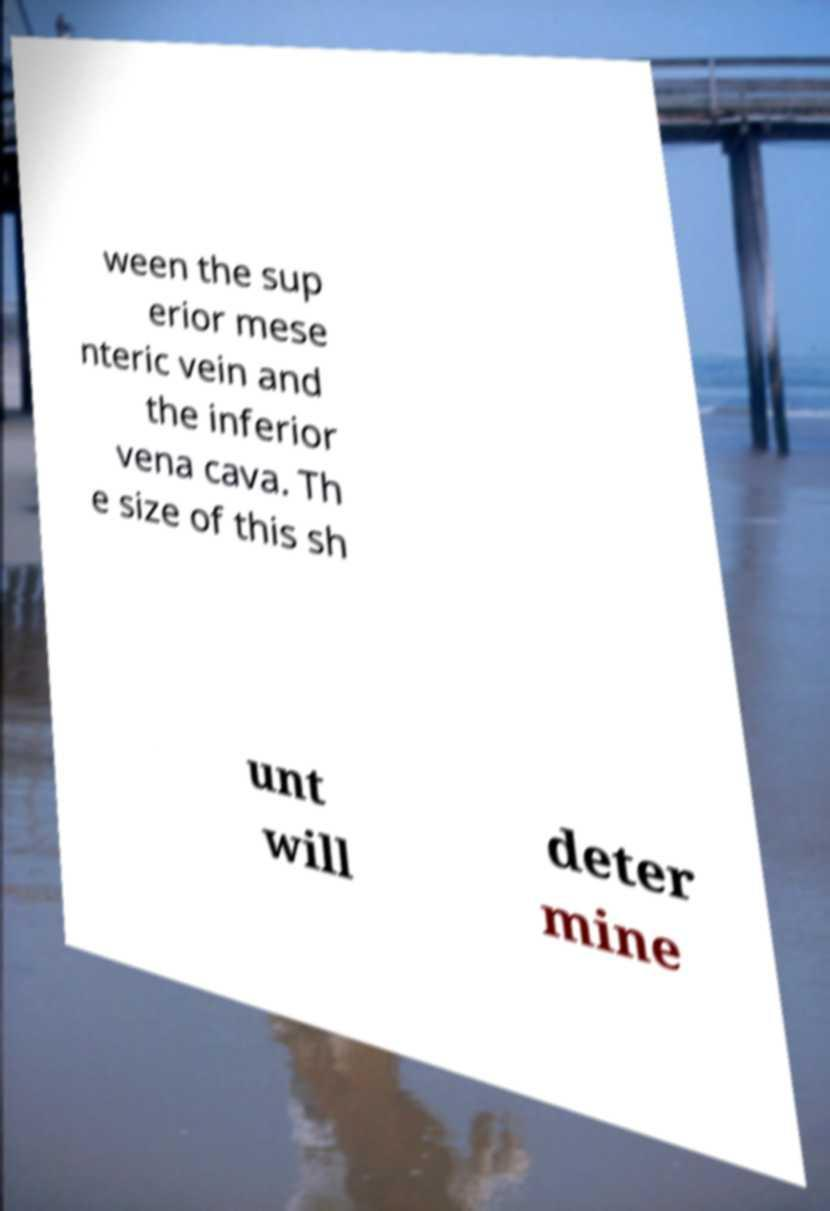I need the written content from this picture converted into text. Can you do that? ween the sup erior mese nteric vein and the inferior vena cava. Th e size of this sh unt will deter mine 